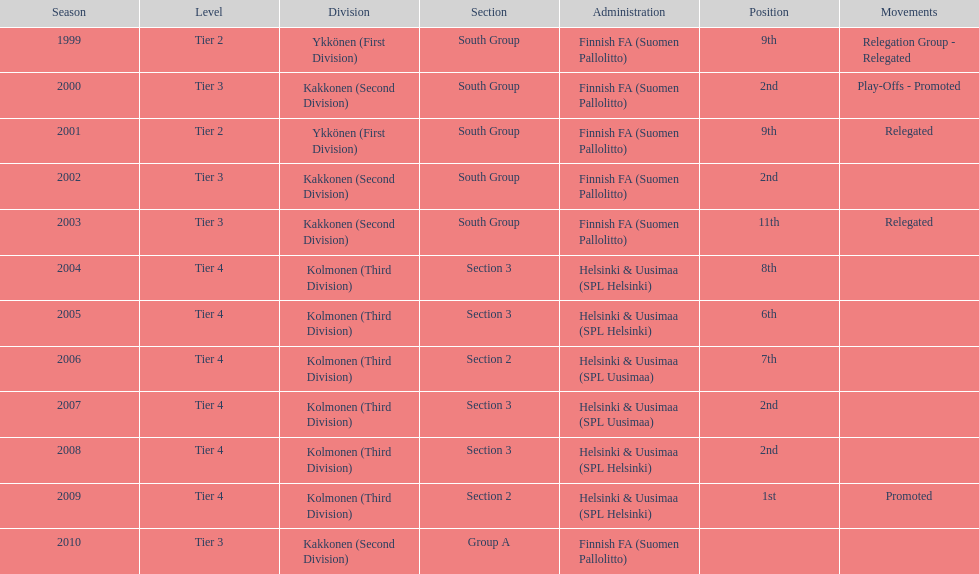In which most recent year did they achieve a 2nd place finish? 2008. Write the full table. {'header': ['Season', 'Level', 'Division', 'Section', 'Administration', 'Position', 'Movements'], 'rows': [['1999', 'Tier 2', 'Ykkönen (First Division)', 'South Group', 'Finnish FA (Suomen Pallolitto)', '9th', 'Relegation Group - Relegated'], ['2000', 'Tier 3', 'Kakkonen (Second Division)', 'South Group', 'Finnish FA (Suomen Pallolitto)', '2nd', 'Play-Offs - Promoted'], ['2001', 'Tier 2', 'Ykkönen (First Division)', 'South Group', 'Finnish FA (Suomen Pallolitto)', '9th', 'Relegated'], ['2002', 'Tier 3', 'Kakkonen (Second Division)', 'South Group', 'Finnish FA (Suomen Pallolitto)', '2nd', ''], ['2003', 'Tier 3', 'Kakkonen (Second Division)', 'South Group', 'Finnish FA (Suomen Pallolitto)', '11th', 'Relegated'], ['2004', 'Tier 4', 'Kolmonen (Third Division)', 'Section 3', 'Helsinki & Uusimaa (SPL Helsinki)', '8th', ''], ['2005', 'Tier 4', 'Kolmonen (Third Division)', 'Section 3', 'Helsinki & Uusimaa (SPL Helsinki)', '6th', ''], ['2006', 'Tier 4', 'Kolmonen (Third Division)', 'Section 2', 'Helsinki & Uusimaa (SPL Uusimaa)', '7th', ''], ['2007', 'Tier 4', 'Kolmonen (Third Division)', 'Section 3', 'Helsinki & Uusimaa (SPL Uusimaa)', '2nd', ''], ['2008', 'Tier 4', 'Kolmonen (Third Division)', 'Section 3', 'Helsinki & Uusimaa (SPL Helsinki)', '2nd', ''], ['2009', 'Tier 4', 'Kolmonen (Third Division)', 'Section 2', 'Helsinki & Uusimaa (SPL Helsinki)', '1st', 'Promoted'], ['2010', 'Tier 3', 'Kakkonen (Second Division)', 'Group A', 'Finnish FA (Suomen Pallolitto)', '', '']]} 